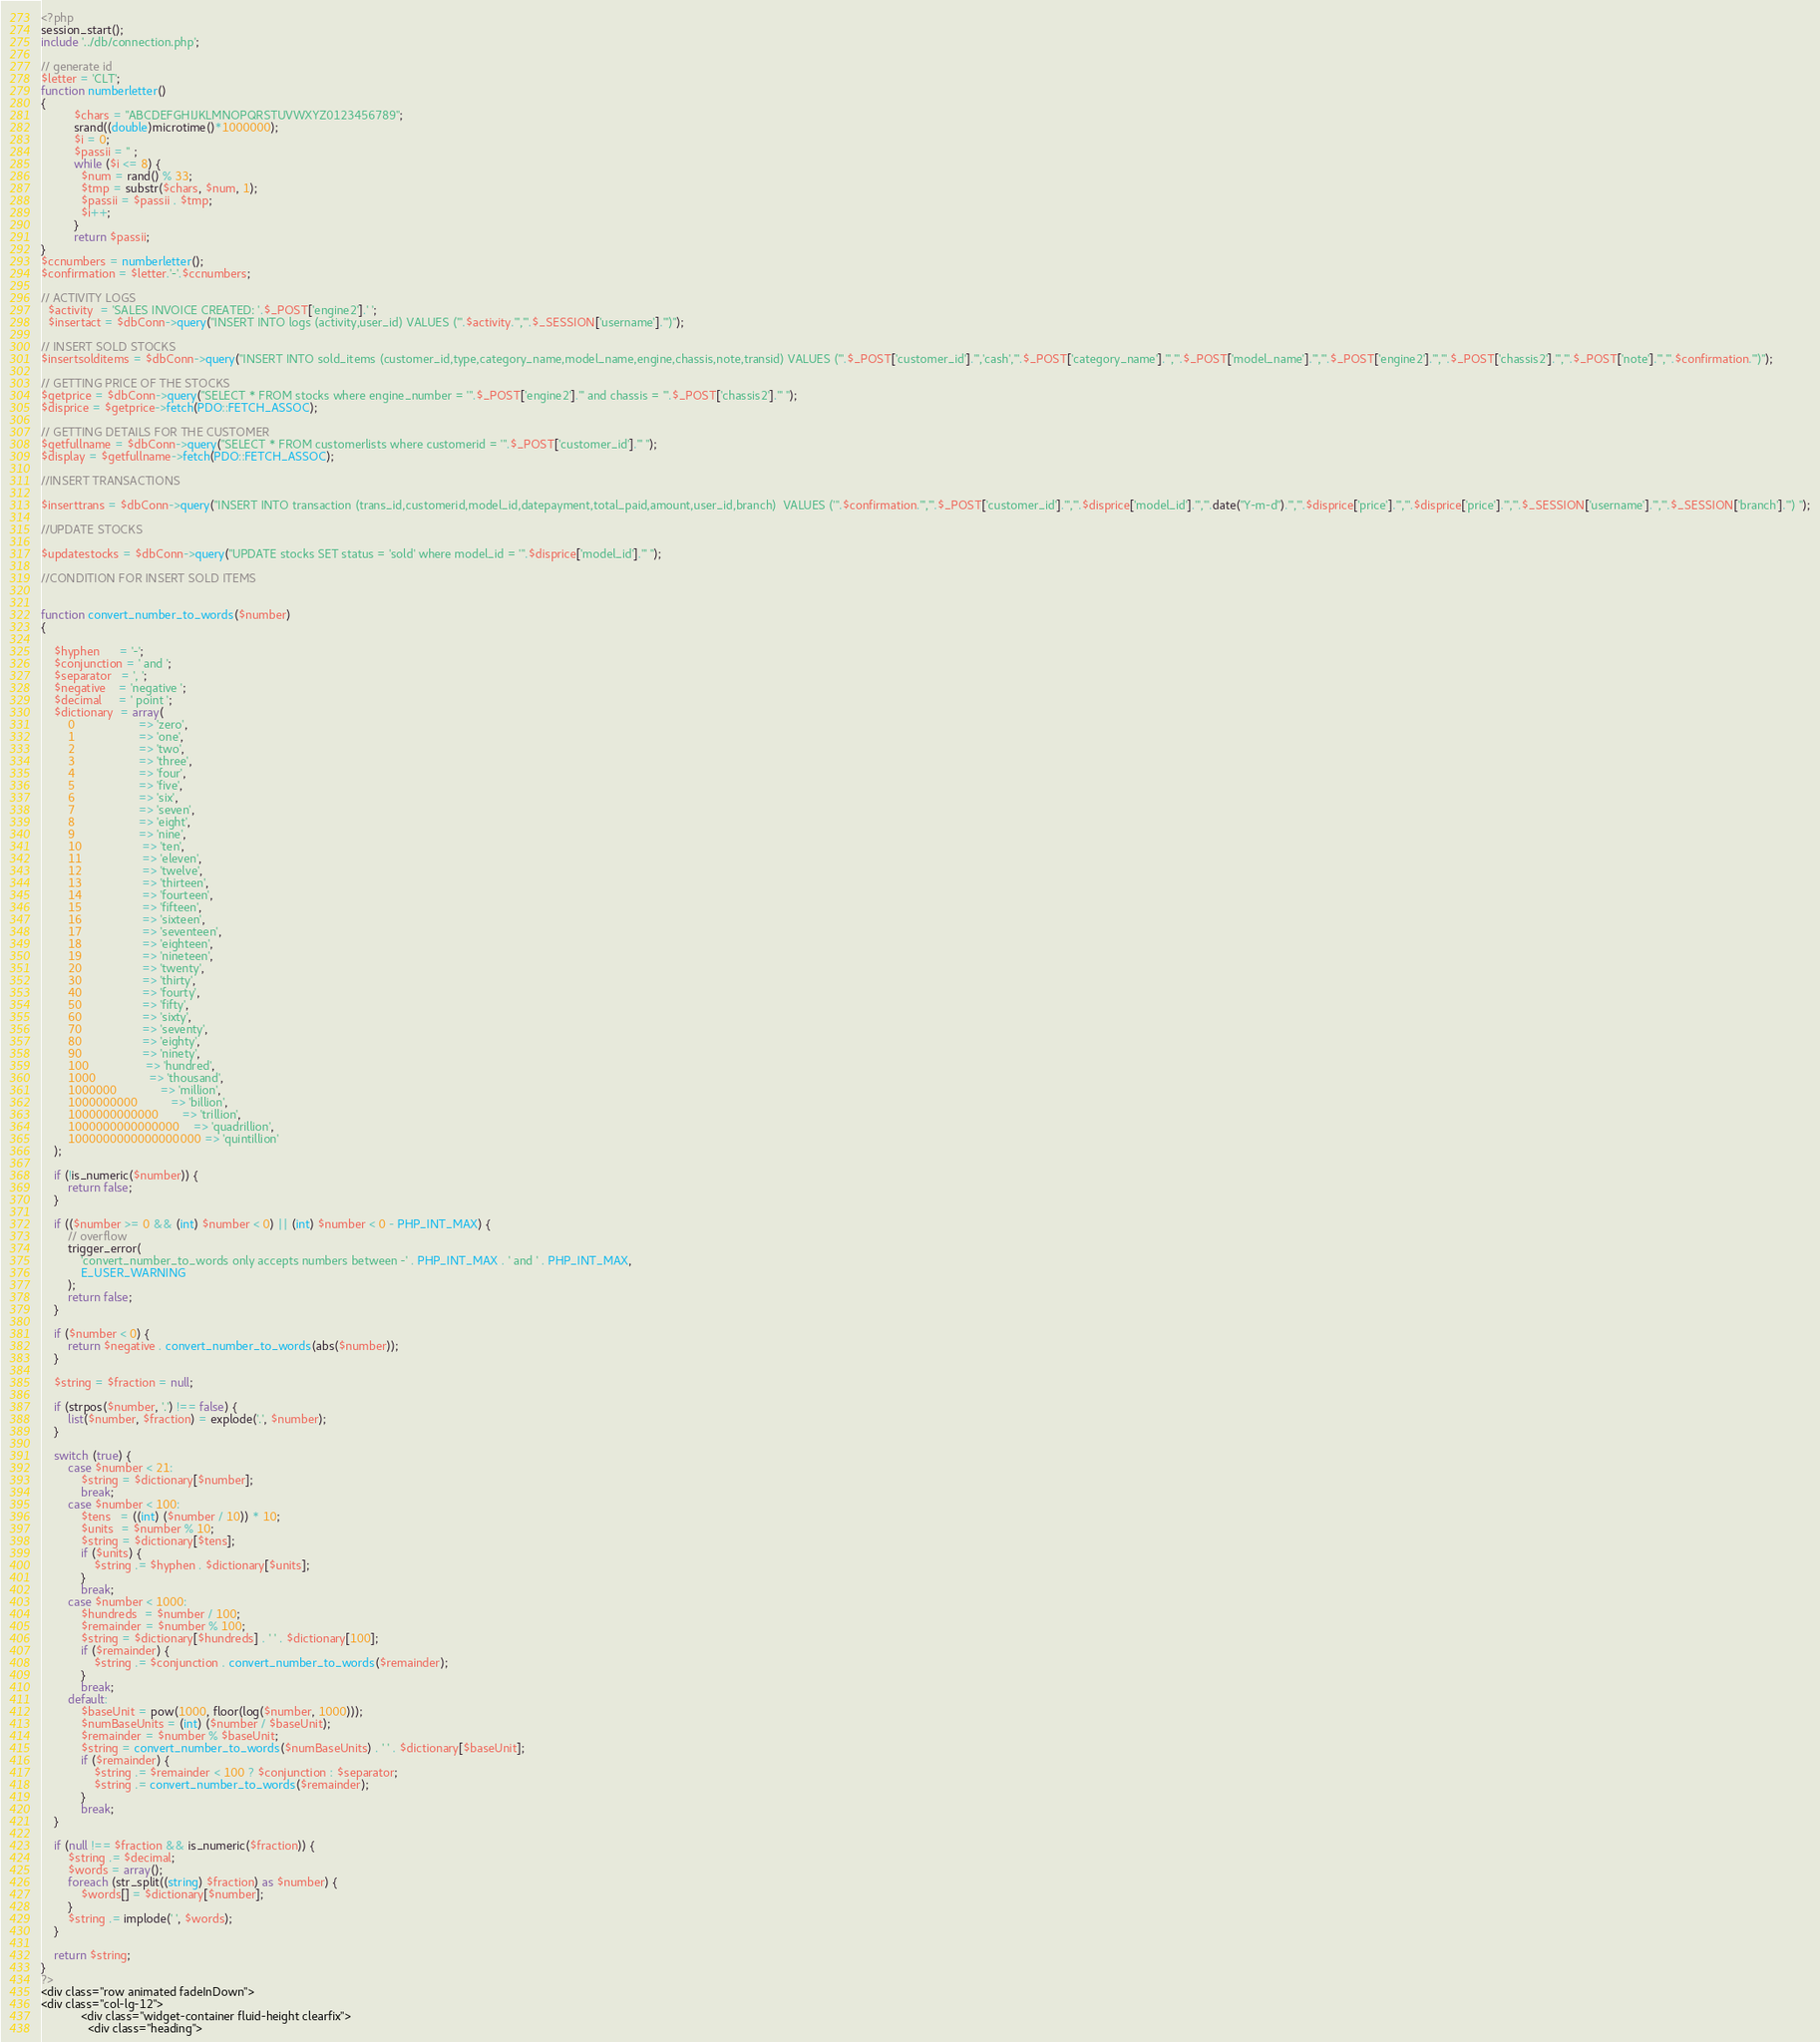Convert code to text. <code><loc_0><loc_0><loc_500><loc_500><_PHP_><?php
session_start();
include '../db/connection.php';

// generate id
$letter = 'CLT';
function numberletter() 
{
          $chars = "ABCDEFGHIJKLMNOPQRSTUVWXYZ0123456789";
          srand((double)microtime()*1000000);
          $i = 0;
          $passii = '' ;
          while ($i <= 8) {
            $num = rand() % 33;
            $tmp = substr($chars, $num, 1);
            $passii = $passii . $tmp;
            $i++;
          }
          return $passii;
}
$ccnumbers = numberletter();
$confirmation = $letter.'-'.$ccnumbers;

// ACTIVITY LOGS
  $activity  = 'SALES INVOICE CREATED: '.$_POST['engine2'].' ';
  $insertact = $dbConn->query("INSERT INTO logs (activity,user_id) VALUES ('".$activity."','".$_SESSION['username']."')");  

// INSERT SOLD STOCKS
$insertsolditems = $dbConn->query("INSERT INTO sold_items (customer_id,type,category_name,model_name,engine,chassis,note,transid) VALUES ('".$_POST['customer_id']."','cash','".$_POST['category_name']."','".$_POST['model_name']."','".$_POST['engine2']."','".$_POST['chassis2']."','".$_POST['note']."','".$confirmation."')");

// GETTING PRICE OF THE STOCKS 
$getprice = $dbConn->query("SELECT * FROM stocks where engine_number = '".$_POST['engine2']."' and chassis = '".$_POST['chassis2']."' ");
$disprice = $getprice->fetch(PDO::FETCH_ASSOC);

// GETTING DETAILS FOR THE CUSTOMER
$getfullname = $dbConn->query("SELECT * FROM customerlists where customerid = '".$_POST['customer_id']."' ");
$display = $getfullname->fetch(PDO::FETCH_ASSOC);

//INSERT TRANSACTIONS

$inserttrans = $dbConn->query("INSERT INTO transaction (trans_id,customerid,model_id,datepayment,total_paid,amount,user_id,branch)  VALUES ('".$confirmation."','".$_POST['customer_id']."','".$disprice['model_id']."','".date("Y-m-d")."','".$disprice['price']."','".$disprice['price']."','".$_SESSION['username']."','".$_SESSION['branch']."') ");

//UPDATE STOCKS

$updatestocks = $dbConn->query("UPDATE stocks SET status = 'sold' where model_id = '".$disprice['model_id']."' ");

//CONDITION FOR INSERT SOLD ITEMS


function convert_number_to_words($number) 
{
    
    $hyphen      = '-';
    $conjunction = ' and ';
    $separator   = ', ';
    $negative    = 'negative ';
    $decimal     = ' point ';
    $dictionary  = array(
        0                   => 'zero',
        1                   => 'one',
        2                   => 'two',
        3                   => 'three',
        4                   => 'four',
        5                   => 'five',
        6                   => 'six',
        7                   => 'seven',
        8                   => 'eight',
        9                   => 'nine',
        10                  => 'ten',
        11                  => 'eleven',
        12                  => 'twelve',
        13                  => 'thirteen',
        14                  => 'fourteen',
        15                  => 'fifteen',
        16                  => 'sixteen',
        17                  => 'seventeen',
        18                  => 'eighteen',
        19                  => 'nineteen',
        20                  => 'twenty',
        30                  => 'thirty',
        40                  => 'fourty',
        50                  => 'fifty',
        60                  => 'sixty',
        70                  => 'seventy',
        80                  => 'eighty',
        90                  => 'ninety',
        100                 => 'hundred',
        1000                => 'thousand',
        1000000             => 'million',
        1000000000          => 'billion',
        1000000000000       => 'trillion',
        1000000000000000    => 'quadrillion',
        1000000000000000000 => 'quintillion'
    );
    
    if (!is_numeric($number)) {
        return false;
    }
    
    if (($number >= 0 && (int) $number < 0) || (int) $number < 0 - PHP_INT_MAX) {
        // overflow
        trigger_error(
            'convert_number_to_words only accepts numbers between -' . PHP_INT_MAX . ' and ' . PHP_INT_MAX,
            E_USER_WARNING
        );
        return false;
    }

    if ($number < 0) {
        return $negative . convert_number_to_words(abs($number));
    }
    
    $string = $fraction = null;
    
    if (strpos($number, '.') !== false) {
        list($number, $fraction) = explode('.', $number);
    }
    
    switch (true) {
        case $number < 21:
            $string = $dictionary[$number];
            break;
        case $number < 100:
            $tens   = ((int) ($number / 10)) * 10;
            $units  = $number % 10;
            $string = $dictionary[$tens];
            if ($units) {
                $string .= $hyphen . $dictionary[$units];
            }
            break;
        case $number < 1000:
            $hundreds  = $number / 100;
            $remainder = $number % 100;
            $string = $dictionary[$hundreds] . ' ' . $dictionary[100];
            if ($remainder) {
                $string .= $conjunction . convert_number_to_words($remainder);
            }
            break;
        default:
            $baseUnit = pow(1000, floor(log($number, 1000)));
            $numBaseUnits = (int) ($number / $baseUnit);
            $remainder = $number % $baseUnit;
            $string = convert_number_to_words($numBaseUnits) . ' ' . $dictionary[$baseUnit];
            if ($remainder) {
                $string .= $remainder < 100 ? $conjunction : $separator;
                $string .= convert_number_to_words($remainder);
            }
            break;
    }
    
    if (null !== $fraction && is_numeric($fraction)) {
        $string .= $decimal;
        $words = array();
        foreach (str_split((string) $fraction) as $number) {
            $words[] = $dictionary[$number];
        }
        $string .= implode(' ', $words);
    }
    
    return $string;
}
?>
<div class="row animated fadeInDown">
<div class="col-lg-12">
            <div class="widget-container fluid-height clearfix">
              <div class="heading"></code> 